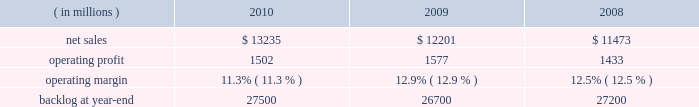The aeronautics segment generally includes fewer programs that have much larger sales and operating results than programs included in the other segments .
Due to the large number of comparatively smaller programs in the remaining segments , the discussion of the results of operations of those business segments focuses on lines of business within the segment rather than on specific programs .
The tables of financial information and related discussion of the results of operations of our business segments are consistent with the presentation of segment information in note 5 to the financial statements .
We have a number of programs that are classified by the u.s .
Government and cannot be specifically described .
The operating results of these classified programs are included in our consolidated and business segment results , and are subjected to the same oversight and internal controls as our other programs .
Aeronautics our aeronautics business segment is engaged in the research , design , development , manufacture , integration , sustainment , support , and upgrade of advanced military aircraft , including combat and air mobility aircraft , unmanned air vehicles , and related technologies .
Key combat aircraft programs include the f-35 lightning ii , f-16 fighting falcon , and f-22 raptor fighter aircraft .
Key air mobility programs include the c-130j super hercules and the c-5m super galaxy .
Aeronautics provides logistics support , sustainment , and upgrade modification services for its aircraft .
Aeronautics 2019 operating results included the following : ( in millions ) 2010 2009 2008 .
Net sales for aeronautics increased by 8% ( 8 % ) in 2010 compared to 2009 .
Sales increased in all three lines of business during the year .
The $ 800 million increase in air mobility primarily was attributable to higher volume on c-130 programs , including deliveries and support activities , as well as higher volume on the c-5 reliability enhancement and re-engining program ( rerp ) .
There were 25 c-130j deliveries in 2010 compared to 16 in 2009 .
The $ 179 million increase in combat aircraft principally was due to higher volume on f-35 production contracts , which partially was offset by lower volume on the f-35 sdd contract and a decline in volume on f-16 , f-22 and other combat aircraft programs .
There were 20 f-16 deliveries in 2010 compared to 31 in 2009 .
The $ 55 million increase in other aeronautics programs mainly was due to higher volume on p-3 and advanced development programs , which partially were offset by a decline in volume on sustainment activities .
Net sales for aeronautics increased by 6% ( 6 % ) in 2009 compared to 2008 .
During the year , sales increased in all three lines of business .
The increase of $ 296 million in air mobility 2019s sales primarily was attributable to higher volume on the c-130 programs , including deliveries and support activities .
There were 16 c-130j deliveries in 2009 and 12 in 2008 .
Combat aircraft sales increased $ 316 million principally due to higher volume on the f-35 program and increases in f-16 deliveries , which partially were offset by lower volume on f-22 and other combat aircraft programs .
There were 31 f-16 deliveries in 2009 compared to 28 in 2008 .
The $ 116 million increase in other aeronautics programs mainly was due to higher volume on p-3 programs and advanced development programs , which partially were offset by declines in sustainment activities .
Operating profit for the segment decreased by 5% ( 5 % ) in 2010 compared to 2009 .
A decline in operating profit in combat aircraft partially was offset by increases in other aeronautics programs and air mobility .
The $ 149 million decrease in combat aircraft 2019s operating profit primarily was due to lower volume and a decrease in the level of favorable performance adjustments on the f-22 program , the f-35 sdd contract and f-16 and other combat aircraft programs in 2010 .
These decreases more than offset increased operating profit resulting from higher volume and improved performance on f-35 production contracts in 2010 .
The $ 35 million increase in other aeronautics programs mainly was attributable to higher volume and improved performance on p-3 and advanced development programs as well as an increase in the level of favorable performance adjustments on sustainment activities in 2010 .
The $ 19 million increase in air mobility operating profit primarily was due to higher volume and improved performance in 2010 on c-130j support activities , which more than offset a decrease in operating profit due to a lower level of favorable performance adjustments on c-130j deliveries in 2010 .
The remaining change in operating profit is attributable to an increase in other income , net between the comparable periods .
Aeronautics 2019 2010 operating margins have decreased when compared to 2009 .
The operating margin decrease reflects the life cycles of our significant programs .
Specifically , aeronautics is performing more development and initial production work on the f-35 program and is performing less work on more mature programs such as the f-22 and f-16 .
Development and initial production contracts yield lower profits than mature full rate programs .
Accordingly , while net sales increased in 2010 relative to 2009 , operating profit decreased and consequently operating margins have declined. .
What were average operating profit for aeronautics in millions from 2008 to 2010? 
Computations: table_average(operating profit, none)
Answer: 1504.0. 